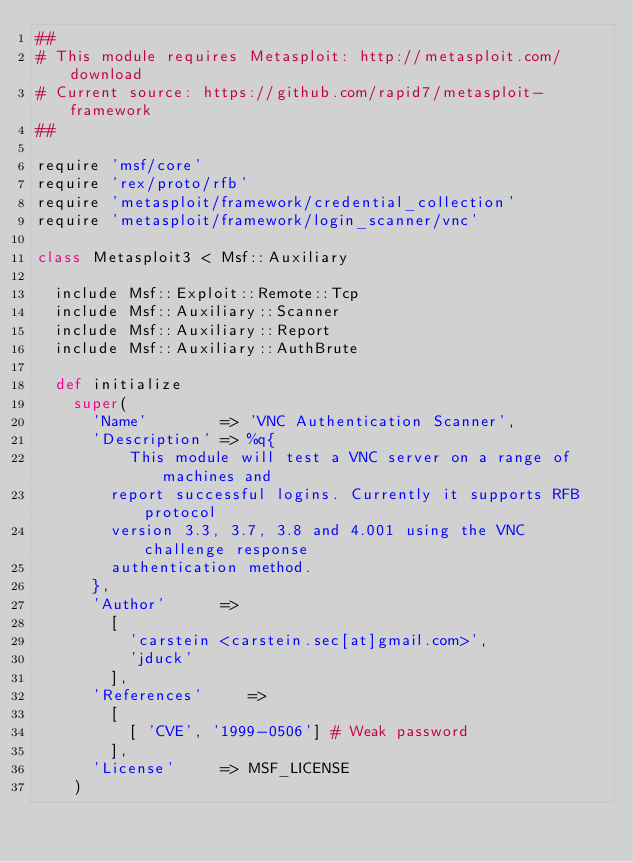Convert code to text. <code><loc_0><loc_0><loc_500><loc_500><_Ruby_>##
# This module requires Metasploit: http://metasploit.com/download
# Current source: https://github.com/rapid7/metasploit-framework
##

require 'msf/core'
require 'rex/proto/rfb'
require 'metasploit/framework/credential_collection'
require 'metasploit/framework/login_scanner/vnc'

class Metasploit3 < Msf::Auxiliary

  include Msf::Exploit::Remote::Tcp
  include Msf::Auxiliary::Scanner
  include Msf::Auxiliary::Report
  include Msf::Auxiliary::AuthBrute

  def initialize
    super(
      'Name'        => 'VNC Authentication Scanner',
      'Description' => %q{
          This module will test a VNC server on a range of machines and
        report successful logins. Currently it supports RFB protocol
        version 3.3, 3.7, 3.8 and 4.001 using the VNC challenge response
        authentication method.
      },
      'Author'      =>
        [
          'carstein <carstein.sec[at]gmail.com>',
          'jduck'
        ],
      'References'     =>
        [
          [ 'CVE', '1999-0506'] # Weak password
        ],
      'License'     => MSF_LICENSE
    )
</code> 